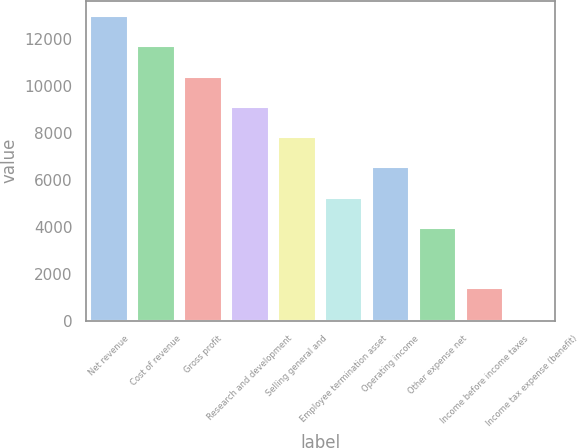Convert chart. <chart><loc_0><loc_0><loc_500><loc_500><bar_chart><fcel>Net revenue<fcel>Cost of revenue<fcel>Gross profit<fcel>Research and development<fcel>Selling general and<fcel>Employee termination asset<fcel>Operating income<fcel>Other expense net<fcel>Income before income taxes<fcel>Income tax expense (benefit)<nl><fcel>12994<fcel>11703.5<fcel>10413<fcel>9122.5<fcel>7832<fcel>5251<fcel>6541.5<fcel>3960.5<fcel>1379.5<fcel>89<nl></chart> 